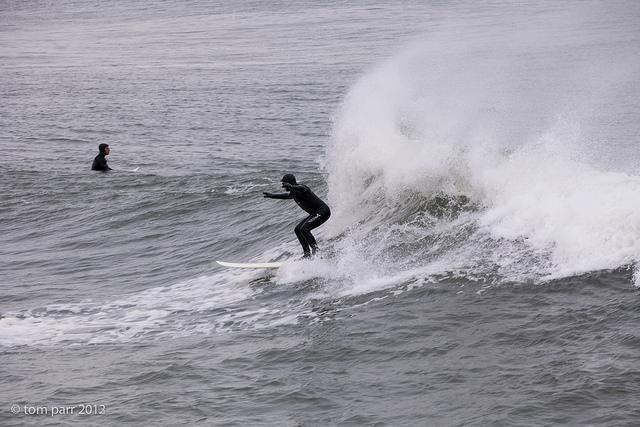How many people are in the shot?
Give a very brief answer. 2. 